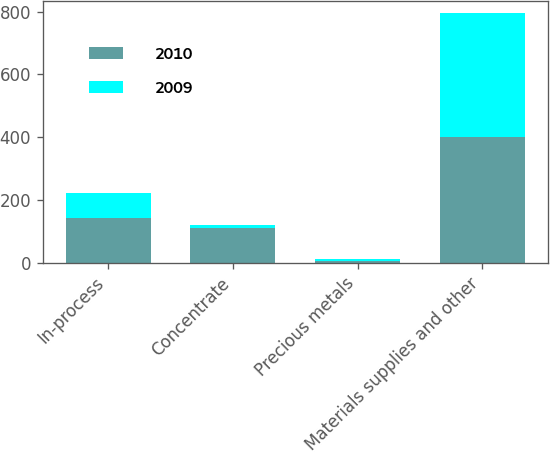Convert chart to OTSL. <chart><loc_0><loc_0><loc_500><loc_500><stacked_bar_chart><ecel><fcel>In-process<fcel>Concentrate<fcel>Precious metals<fcel>Materials supplies and other<nl><fcel>2010<fcel>142<fcel>111<fcel>4<fcel>401<nl><fcel>2009<fcel>80<fcel>10<fcel>9<fcel>394<nl></chart> 